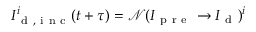Convert formula to latex. <formula><loc_0><loc_0><loc_500><loc_500>I _ { d , i n c } ^ { i } ( t + \tau ) = \mathcal { N } ( I _ { p r e } \rightarrow I _ { d } ) ^ { i }</formula> 